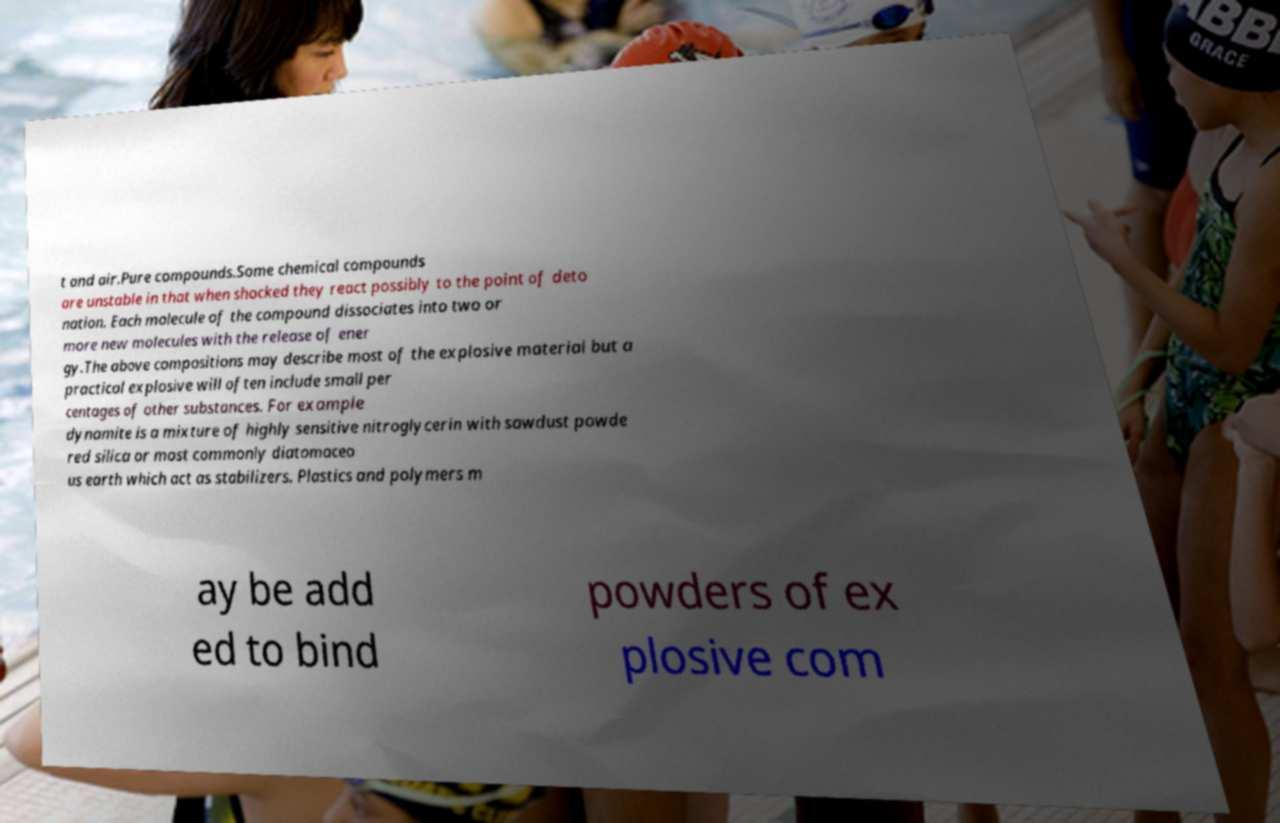Could you extract and type out the text from this image? t and air.Pure compounds.Some chemical compounds are unstable in that when shocked they react possibly to the point of deto nation. Each molecule of the compound dissociates into two or more new molecules with the release of ener gy.The above compositions may describe most of the explosive material but a practical explosive will often include small per centages of other substances. For example dynamite is a mixture of highly sensitive nitroglycerin with sawdust powde red silica or most commonly diatomaceo us earth which act as stabilizers. Plastics and polymers m ay be add ed to bind powders of ex plosive com 